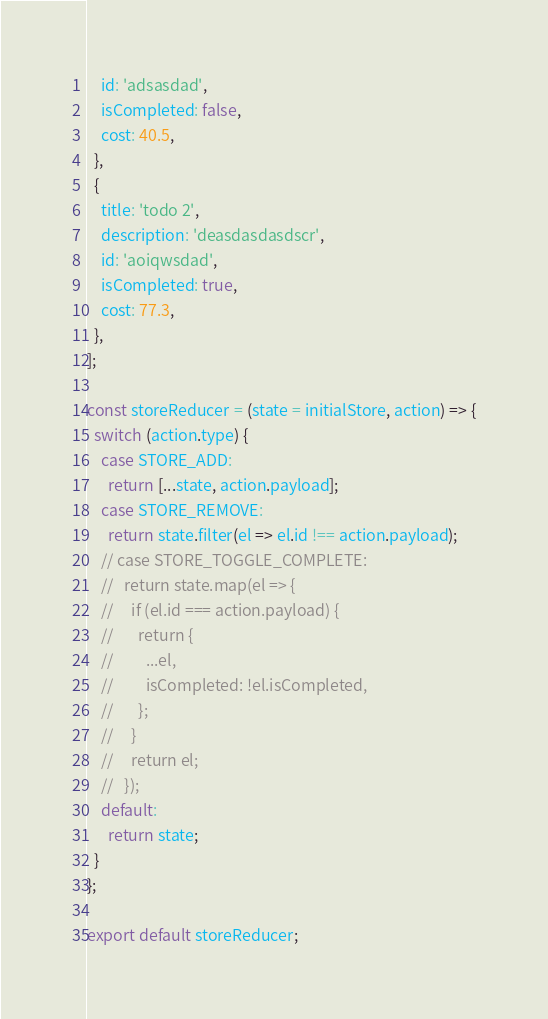Convert code to text. <code><loc_0><loc_0><loc_500><loc_500><_JavaScript_>    id: 'adsasdad',
    isCompleted: false,
    cost: 40.5,
  },
  {
    title: 'todo 2',
    description: 'deasdasdasdscr',
    id: 'aoiqwsdad',
    isCompleted: true,
    cost: 77.3,
  },
];

const storeReducer = (state = initialStore, action) => {
  switch (action.type) {
    case STORE_ADD:
      return [...state, action.payload];
    case STORE_REMOVE:
      return state.filter(el => el.id !== action.payload);
    // case STORE_TOGGLE_COMPLETE:
    //   return state.map(el => {
    //     if (el.id === action.payload) {
    //       return {
    //         ...el,
    //         isCompleted: !el.isCompleted,
    //       };
    //     }
    //     return el;
    //   });
    default:
      return state;
  }
};

export default storeReducer;
</code> 